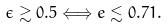Convert formula to latex. <formula><loc_0><loc_0><loc_500><loc_500>\epsilon \gtrsim 0 . 5 \Longleftrightarrow e \lesssim 0 . 7 1 .</formula> 